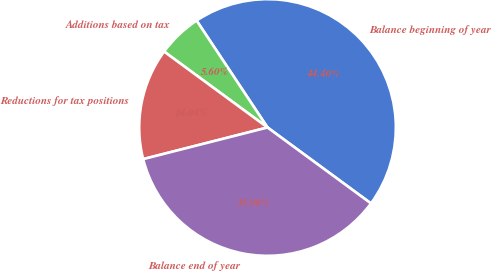<chart> <loc_0><loc_0><loc_500><loc_500><pie_chart><fcel>Balance beginning of year<fcel>Additions based on tax<fcel>Reductions for tax positions<fcel>Balance end of year<nl><fcel>44.4%<fcel>5.6%<fcel>14.04%<fcel>35.96%<nl></chart> 